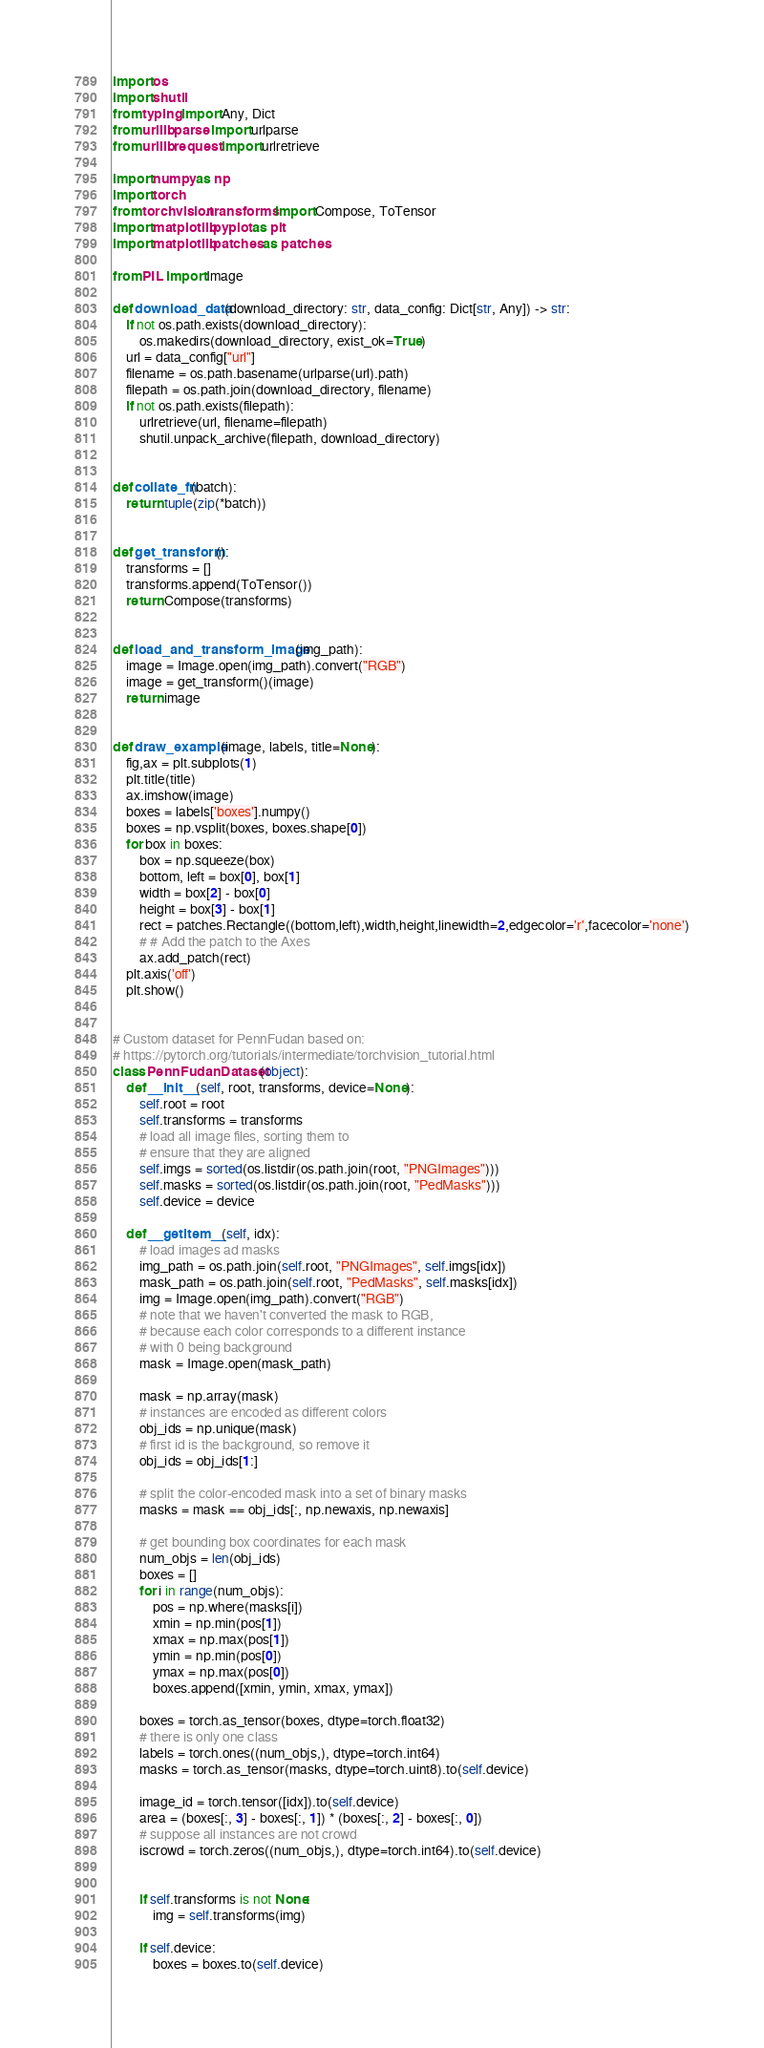Convert code to text. <code><loc_0><loc_0><loc_500><loc_500><_Python_>import os
import shutil
from typing import Any, Dict
from urllib.parse import urlparse
from urllib.request import urlretrieve

import numpy as np
import torch
from torchvision.transforms import Compose, ToTensor
import matplotlib.pyplot as plt
import matplotlib.patches as patches

from PIL import Image

def download_data(download_directory: str, data_config: Dict[str, Any]) -> str:
    if not os.path.exists(download_directory):
        os.makedirs(download_directory, exist_ok=True)
    url = data_config["url"]
    filename = os.path.basename(urlparse(url).path)
    filepath = os.path.join(download_directory, filename)
    if not os.path.exists(filepath):
        urlretrieve(url, filename=filepath)
        shutil.unpack_archive(filepath, download_directory)


def collate_fn(batch):
    return tuple(zip(*batch))


def get_transform():
    transforms = []
    transforms.append(ToTensor())
    return Compose(transforms)


def load_and_transform_image(img_path):
    image = Image.open(img_path).convert("RGB")
    image = get_transform()(image)
    return image


def draw_example(image, labels, title=None):
    fig,ax = plt.subplots(1)
    plt.title(title)
    ax.imshow(image)
    boxes = labels['boxes'].numpy()
    boxes = np.vsplit(boxes, boxes.shape[0])
    for box in boxes:
        box = np.squeeze(box)
        bottom, left = box[0], box[1]
        width = box[2] - box[0]
        height = box[3] - box[1]
        rect = patches.Rectangle((bottom,left),width,height,linewidth=2,edgecolor='r',facecolor='none')
        # # Add the patch to the Axes
        ax.add_patch(rect)
    plt.axis('off')
    plt.show()


# Custom dataset for PennFudan based on:
# https://pytorch.org/tutorials/intermediate/torchvision_tutorial.html
class PennFudanDataset(object):
    def __init__(self, root, transforms, device=None):
        self.root = root
        self.transforms = transforms
        # load all image files, sorting them to
        # ensure that they are aligned
        self.imgs = sorted(os.listdir(os.path.join(root, "PNGImages")))
        self.masks = sorted(os.listdir(os.path.join(root, "PedMasks")))
        self.device = device

    def __getitem__(self, idx):
        # load images ad masks
        img_path = os.path.join(self.root, "PNGImages", self.imgs[idx])
        mask_path = os.path.join(self.root, "PedMasks", self.masks[idx])
        img = Image.open(img_path).convert("RGB")
        # note that we haven't converted the mask to RGB,
        # because each color corresponds to a different instance
        # with 0 being background
        mask = Image.open(mask_path)

        mask = np.array(mask)
        # instances are encoded as different colors
        obj_ids = np.unique(mask)
        # first id is the background, so remove it
        obj_ids = obj_ids[1:]

        # split the color-encoded mask into a set of binary masks
        masks = mask == obj_ids[:, np.newaxis, np.newaxis]

        # get bounding box coordinates for each mask
        num_objs = len(obj_ids)
        boxes = []
        for i in range(num_objs):
            pos = np.where(masks[i])
            xmin = np.min(pos[1])
            xmax = np.max(pos[1])
            ymin = np.min(pos[0])
            ymax = np.max(pos[0])
            boxes.append([xmin, ymin, xmax, ymax])

        boxes = torch.as_tensor(boxes, dtype=torch.float32)
        # there is only one class
        labels = torch.ones((num_objs,), dtype=torch.int64)
        masks = torch.as_tensor(masks, dtype=torch.uint8).to(self.device)

        image_id = torch.tensor([idx]).to(self.device)
        area = (boxes[:, 3] - boxes[:, 1]) * (boxes[:, 2] - boxes[:, 0])
        # suppose all instances are not crowd
        iscrowd = torch.zeros((num_objs,), dtype=torch.int64).to(self.device)


        if self.transforms is not None:
            img = self.transforms(img)

        if self.device:
            boxes = boxes.to(self.device)</code> 